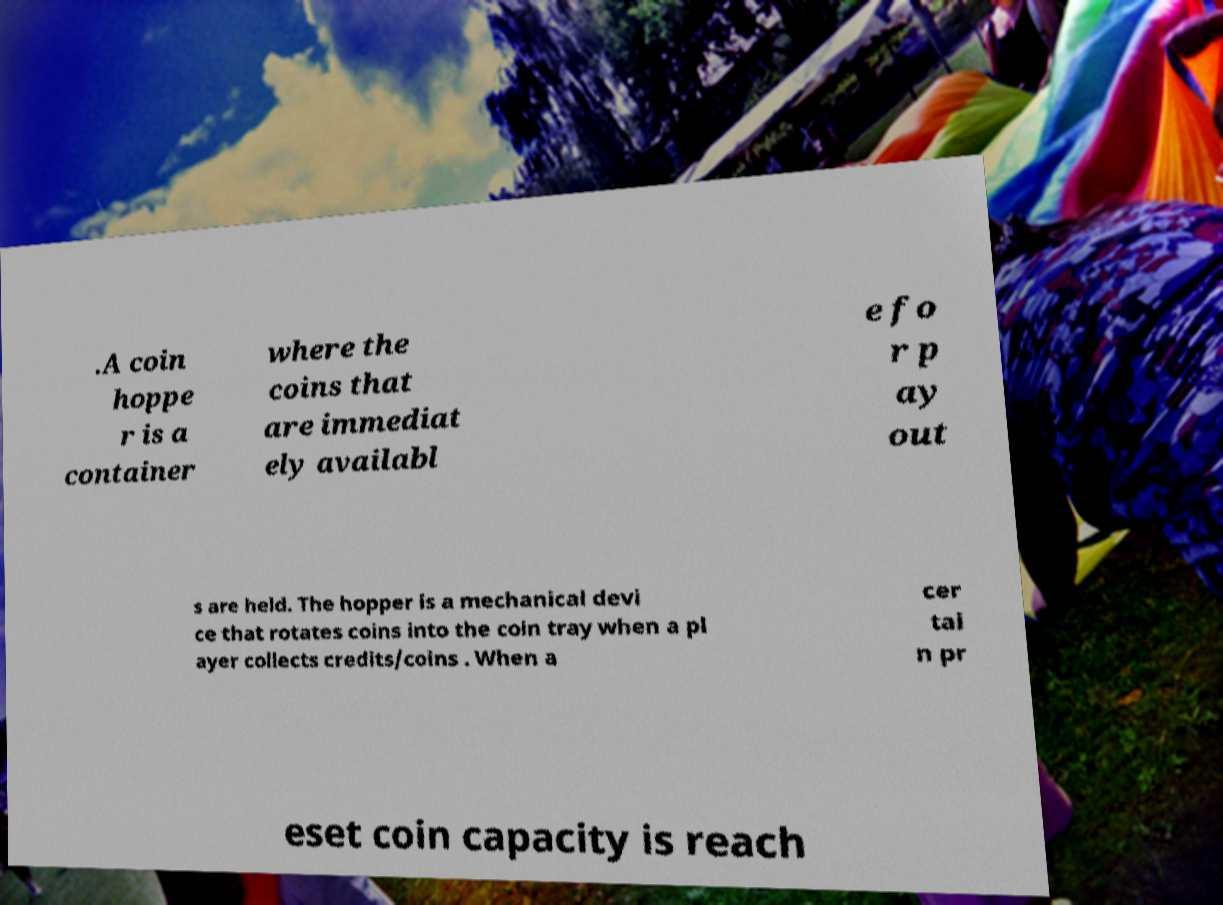Can you accurately transcribe the text from the provided image for me? .A coin hoppe r is a container where the coins that are immediat ely availabl e fo r p ay out s are held. The hopper is a mechanical devi ce that rotates coins into the coin tray when a pl ayer collects credits/coins . When a cer tai n pr eset coin capacity is reach 